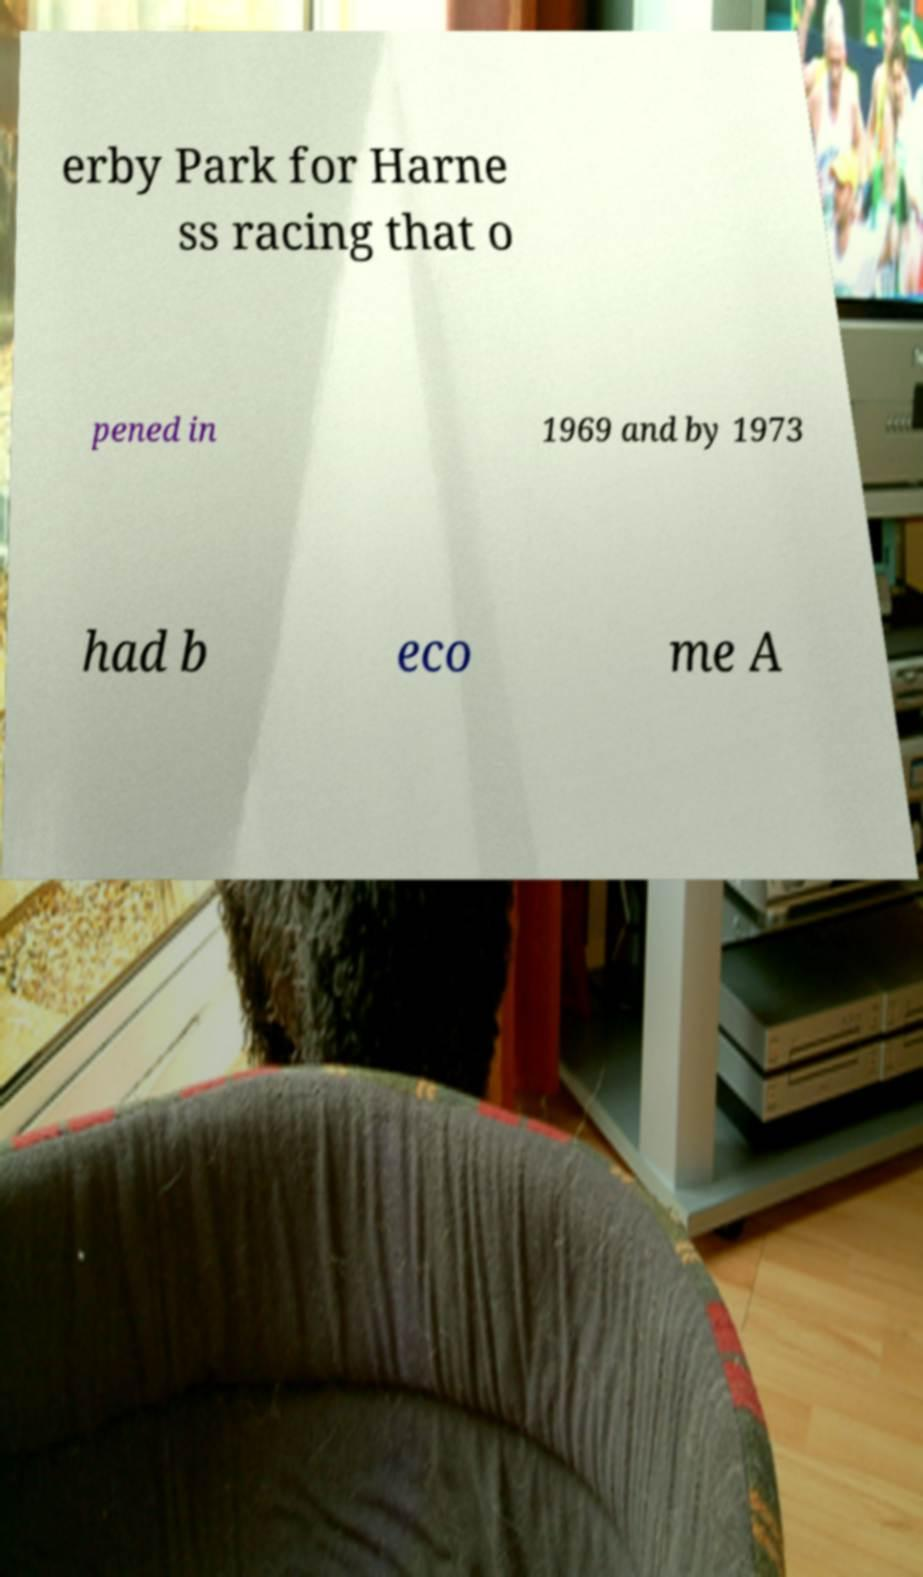There's text embedded in this image that I need extracted. Can you transcribe it verbatim? erby Park for Harne ss racing that o pened in 1969 and by 1973 had b eco me A 